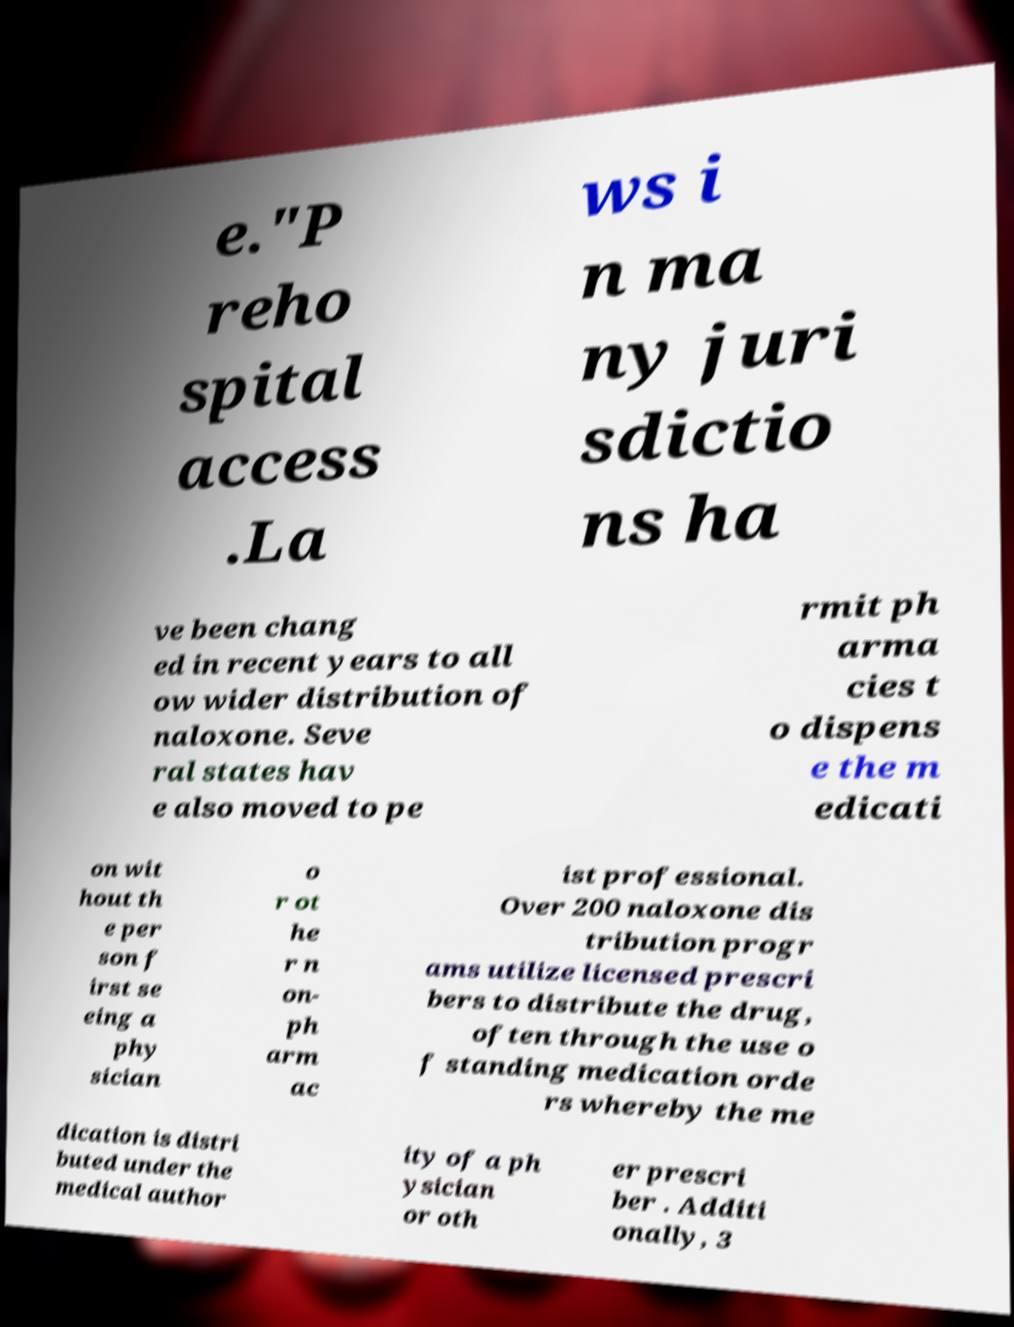What messages or text are displayed in this image? I need them in a readable, typed format. e."P reho spital access .La ws i n ma ny juri sdictio ns ha ve been chang ed in recent years to all ow wider distribution of naloxone. Seve ral states hav e also moved to pe rmit ph arma cies t o dispens e the m edicati on wit hout th e per son f irst se eing a phy sician o r ot he r n on- ph arm ac ist professional. Over 200 naloxone dis tribution progr ams utilize licensed prescri bers to distribute the drug, often through the use o f standing medication orde rs whereby the me dication is distri buted under the medical author ity of a ph ysician or oth er prescri ber . Additi onally, 3 